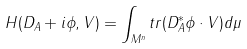Convert formula to latex. <formula><loc_0><loc_0><loc_500><loc_500>H ( D _ { A } + i \phi , V ) = \int _ { M ^ { n } } t r ( D ^ { * } _ { A } \phi \cdot V ) d \mu</formula> 